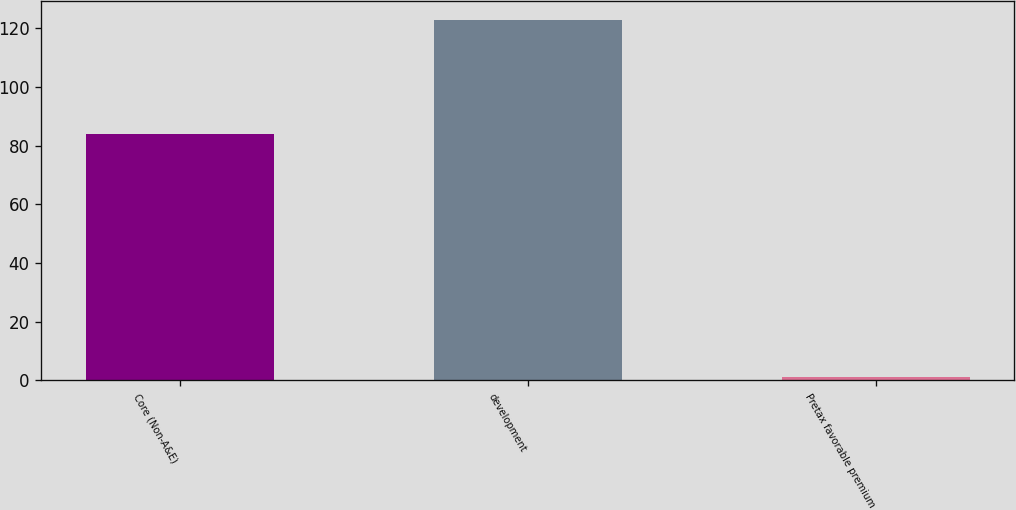Convert chart. <chart><loc_0><loc_0><loc_500><loc_500><bar_chart><fcel>Core (Non-A&E)<fcel>development<fcel>Pretax favorable premium<nl><fcel>84<fcel>123<fcel>1<nl></chart> 